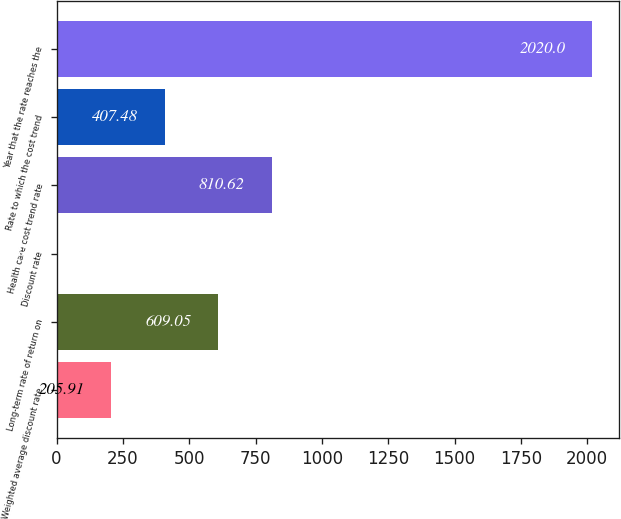Convert chart. <chart><loc_0><loc_0><loc_500><loc_500><bar_chart><fcel>Weighted average discount rate<fcel>Long-term rate of return on<fcel>Discount rate<fcel>Health care cost trend rate<fcel>Rate to which the cost trend<fcel>Year that the rate reaches the<nl><fcel>205.91<fcel>609.05<fcel>4.34<fcel>810.62<fcel>407.48<fcel>2020<nl></chart> 